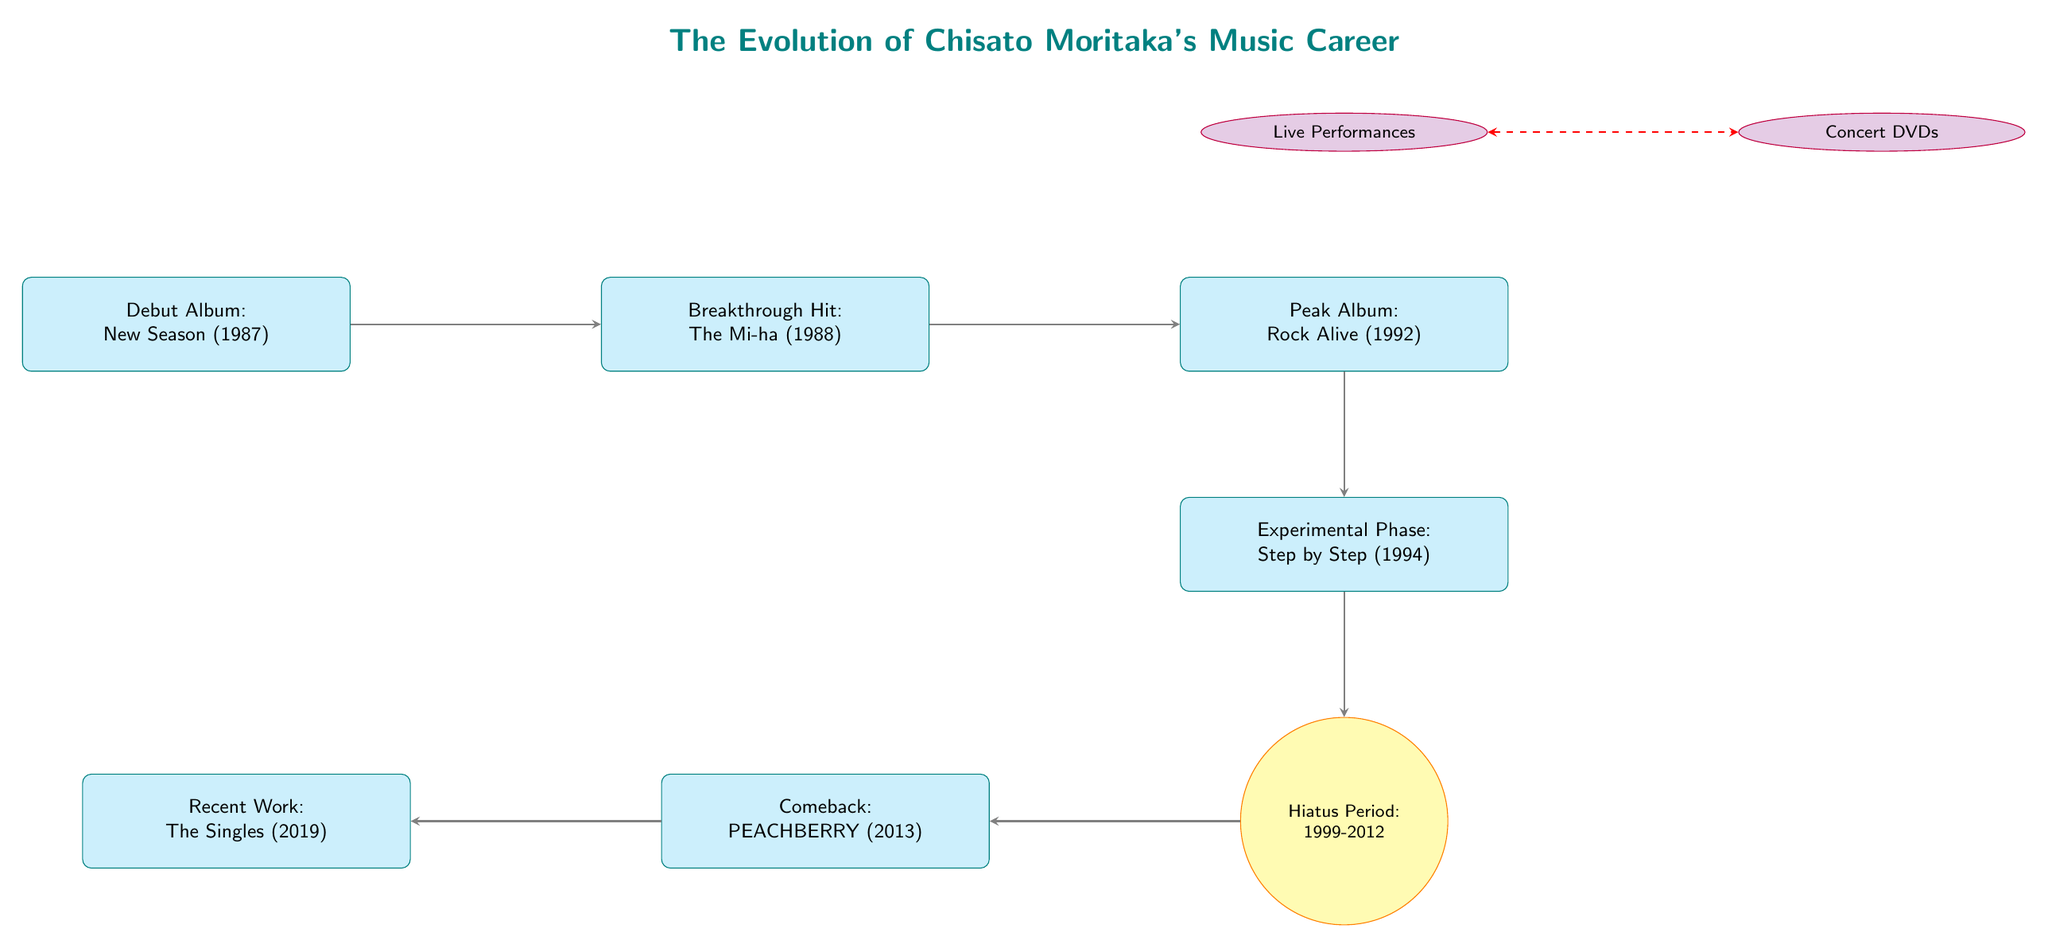What is the title of Chisato Moritaka's debut album? The diagram clearly labels the first node, which is connected to the subsequent nodes, and it contains the title "New Season (1987)."
Answer: New Season (1987) What year did Chisato Moritaka have her breakthrough hit? The diagram indicates that her breakthrough hit occurred in 1988, as shown in the second node labeled "The Mi-ha (1988)."
Answer: 1988 How many key albums are mentioned in the diagram? Counting the album nodes from the diagram, there are five key albums listed: New Season, The Mi-ha, Rock Alive, Step by Step, and PEACHBERRY.
Answer: 5 What significant period in Chisato Moritaka's career is shown between 1999 and 2012? The diagram contains a milestone node specifically labeled "Hiatus Period: 1999-2012," indicating this important time in her career.
Answer: Hiatus Period: 1999-2012 What is highlighted above the album "Rock Alive"? The diagram shows a collection node labeled "Live Performances" directly above the album "Rock Alive," indicating that live performances are an important aspect of her career.
Answer: Live Performances What notable album did Chisato Moritaka release in 2013? The diagram displays the node labeled "Comeback: PEACHBERRY (2013)," which clearly indicates the title and year of her comeback album.
Answer: PEACHBERRY (2013) What is the relationship between concert performances and concert DVDs in the diagram? The diagram illustrates a double-headed arrow connecting the nodes "Live Performances" and "Concert DVDs," indicating a mutual relationship between these two collections.
Answer: Related Which album represents the peak of her music career according to the diagram? The node labeled "Peak Album: Rock Alive (1992)" has been specifically designated as the peak in her career timeline, according to the diagram's structure.
Answer: Rock Alive (1992) Which album comes immediately after the experimental phase in Chisato Moritaka's career timeline? The edge leading from the node "Experimental Phase: Step by Step (1994)" goes directly to the milestone node "Hiatus Period: 1999-2012," indicating there's no album mentioned right after the experimental phase since it transitions to a hiatus.
Answer: Hiatus Period: 1999-2012 